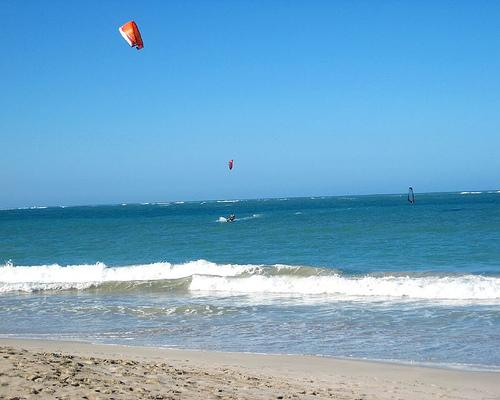To what is this sail attached? Please explain your reasoning. surfer. The sail is on the surfer. 